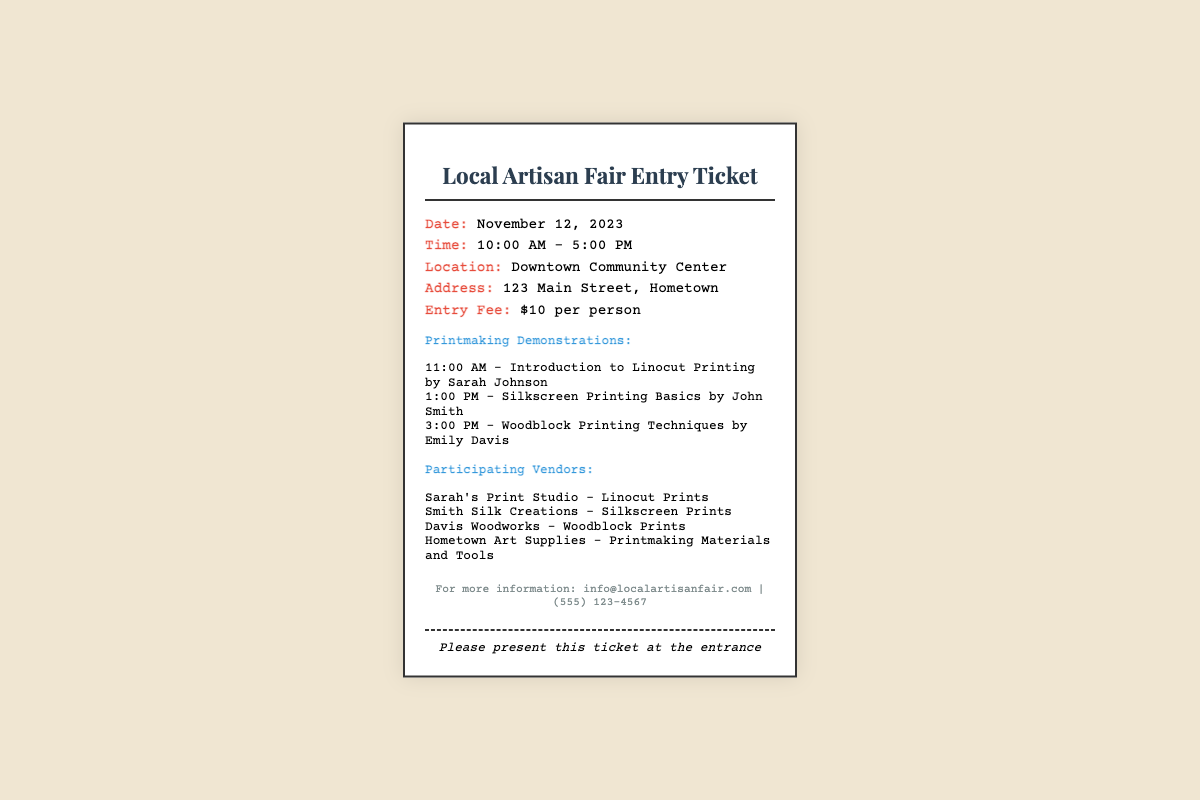what is the date of the fair? The date of the fair is stated in the document to be November 12, 2023.
Answer: November 12, 2023 what is the entry fee? The entry fee for the event is mentioned in the document as $10 per person.
Answer: $10 per person who is presenting the Silkscreen Printing demonstration? The document states that John Smith is presenting the Silkscreen Printing demonstration.
Answer: John Smith how many printmaking demonstrations are scheduled? The document lists three printmaking demonstrations scheduled throughout the day.
Answer: Three what time does the fair start? The starting time of the fair is indicated in the document as 10:00 AM.
Answer: 10:00 AM which vendor specializes in woodblock prints? The document mentions Davis Woodworks as the vendor specializing in woodblock prints.
Answer: Davis Woodworks where is the fair located? The location of the fair is provided in the document as Downtown Community Center.
Answer: Downtown Community Center what is the contact email for more information? The document provides an email address for inquiries which is info@localartisanfair.com.
Answer: info@localartisanfair.com 